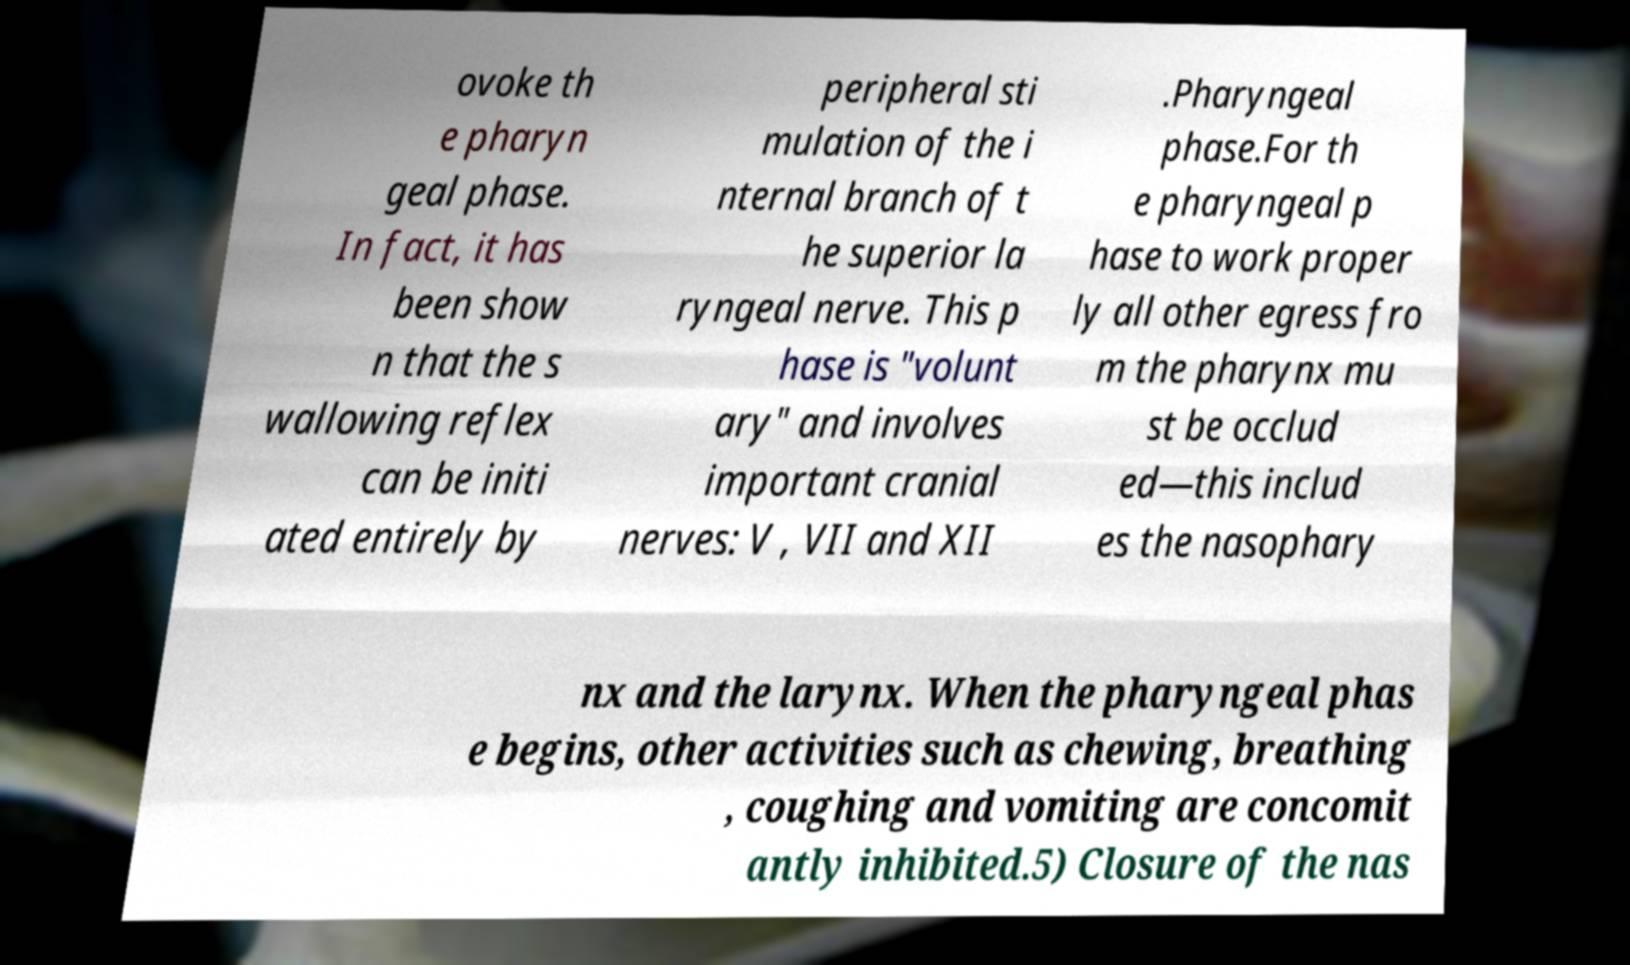Could you assist in decoding the text presented in this image and type it out clearly? ovoke th e pharyn geal phase. In fact, it has been show n that the s wallowing reflex can be initi ated entirely by peripheral sti mulation of the i nternal branch of t he superior la ryngeal nerve. This p hase is "volunt ary" and involves important cranial nerves: V , VII and XII .Pharyngeal phase.For th e pharyngeal p hase to work proper ly all other egress fro m the pharynx mu st be occlud ed—this includ es the nasophary nx and the larynx. When the pharyngeal phas e begins, other activities such as chewing, breathing , coughing and vomiting are concomit antly inhibited.5) Closure of the nas 